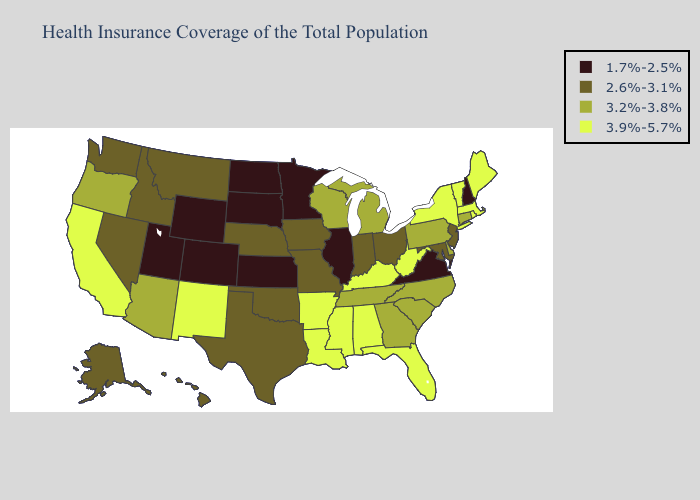What is the value of Oregon?
Be succinct. 3.2%-3.8%. What is the lowest value in states that border Kentucky?
Concise answer only. 1.7%-2.5%. Does Connecticut have the highest value in the Northeast?
Quick response, please. No. What is the lowest value in the Northeast?
Answer briefly. 1.7%-2.5%. Name the states that have a value in the range 3.2%-3.8%?
Give a very brief answer. Arizona, Connecticut, Delaware, Georgia, Michigan, North Carolina, Oregon, Pennsylvania, South Carolina, Tennessee, Wisconsin. Does Texas have the highest value in the South?
Quick response, please. No. What is the highest value in states that border South Carolina?
Be succinct. 3.2%-3.8%. What is the highest value in the USA?
Short answer required. 3.9%-5.7%. Is the legend a continuous bar?
Quick response, please. No. Among the states that border Texas , does New Mexico have the highest value?
Answer briefly. Yes. What is the value of North Dakota?
Quick response, please. 1.7%-2.5%. What is the value of Nebraska?
Quick response, please. 2.6%-3.1%. What is the value of Iowa?
Keep it brief. 2.6%-3.1%. Does Colorado have the highest value in the USA?
Quick response, please. No. 